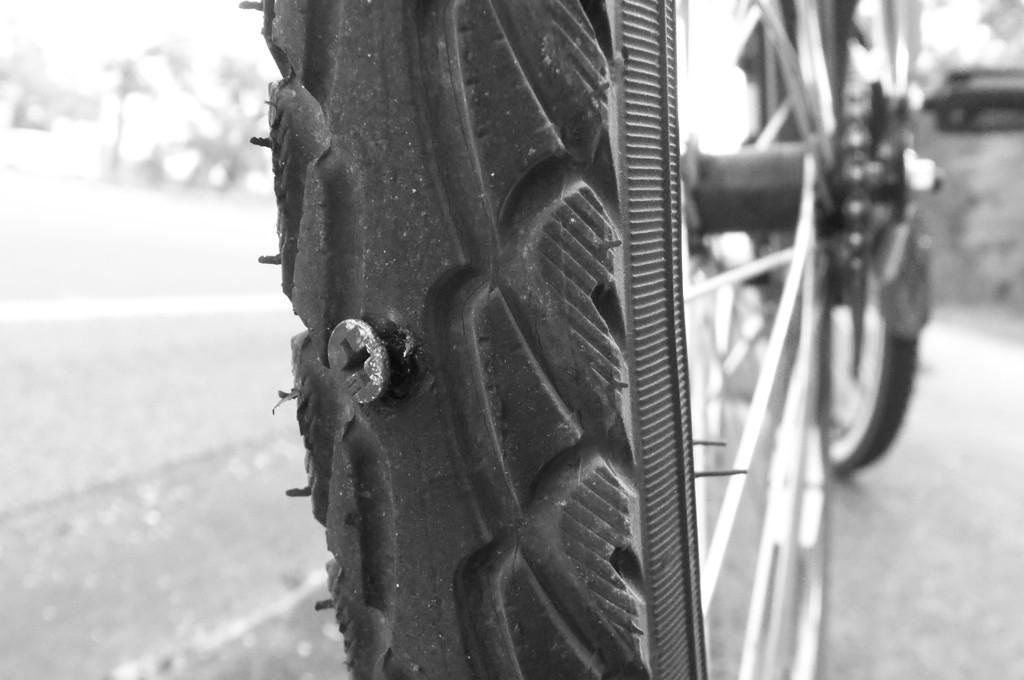What object is present in the Tyre in the image? There is a screw in the Tyre. What type of vehicle might the Tyre belong to? The Tyre appears to be part of a cycle. What type of pot is visible in the image? There is no pot present in the image. What type of expansion can be seen in the image? There is no expansion visible in the image. What type of apparatus is present in the image? The image only features a Tyre with a screw in it, and there is no apparatus present. 